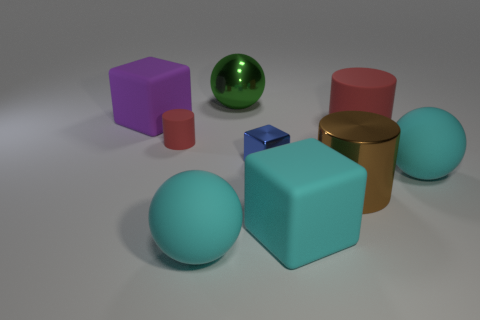There is a matte cylinder to the left of the big cyan rubber block; is its color the same as the large metallic object in front of the big rubber cylinder?
Offer a terse response. No. How many things are either purple shiny cubes or purple matte things?
Keep it short and to the point. 1. How many other things are there of the same shape as the large brown thing?
Keep it short and to the point. 2. Is the material of the cylinder behind the small matte object the same as the tiny thing behind the small blue object?
Ensure brevity in your answer.  Yes. What shape is the metallic thing that is in front of the purple cube and left of the brown metallic cylinder?
Offer a terse response. Cube. Is there any other thing that has the same material as the tiny red object?
Offer a very short reply. Yes. What material is the block that is both to the left of the cyan matte block and right of the large purple block?
Give a very brief answer. Metal. There is a tiny object that is the same material as the large green thing; what is its shape?
Give a very brief answer. Cube. Is there any other thing of the same color as the large rubber cylinder?
Keep it short and to the point. Yes. Is the number of blocks behind the big brown shiny cylinder greater than the number of large objects?
Make the answer very short. No. 